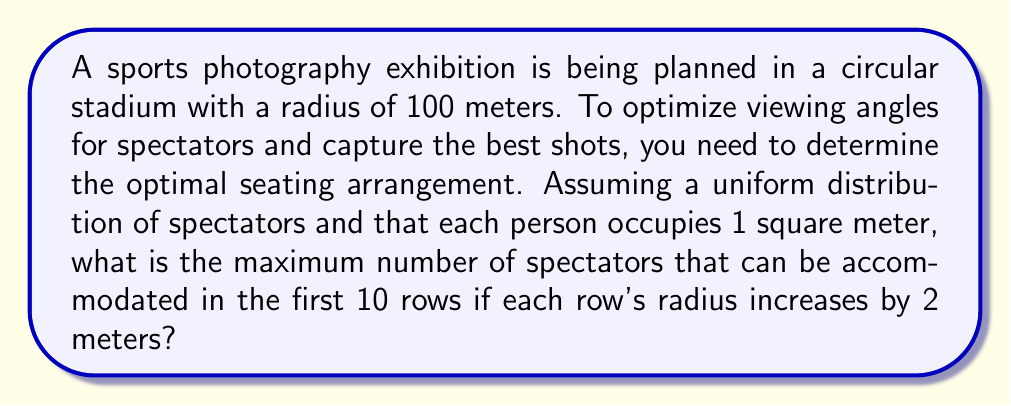What is the answer to this math problem? Let's approach this step-by-step:

1) The area of a circular ring is given by the formula:
   $$A = \pi(R^2 - r^2)$$
   where R is the outer radius and r is the inner radius.

2) For the first row:
   Inner radius (r) = 100 m
   Outer radius (R) = 102 m
   Area = $$\pi(102^2 - 100^2) = 628.32 \text{ m}^2$$

3) For the second row:
   Inner radius (r) = 102 m
   Outer radius (R) = 104 m
   Area = $$\pi(104^2 - 102^2) = 641.15 \text{ m}^2$$

4) We can generalize this for the nth row:
   Area of nth row = $$\pi((100 + 2n)^2 - (98 + 2n)^2)$$
                   = $$4\pi(99 + n)$$

5) To find the total area for 10 rows, we sum this from n = 1 to 10:
   $$\text{Total Area} = \sum_{n=1}^{10} 4\pi(99 + n)$$
                       = $$4\pi\sum_{n=1}^{10} (99 + n)$$
                       = $$4\pi(990 + \sum_{n=1}^{10} n)$$
                       = $$4\pi(990 + 55)$$
                       = $$4\pi(1045)$$
                       = $$13,131.73 \text{ m}^2$$

6) Since each spectator occupies 1 square meter, the maximum number of spectators is the floor of this area.
Answer: 13,131 